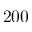<formula> <loc_0><loc_0><loc_500><loc_500>2 0 0</formula> 